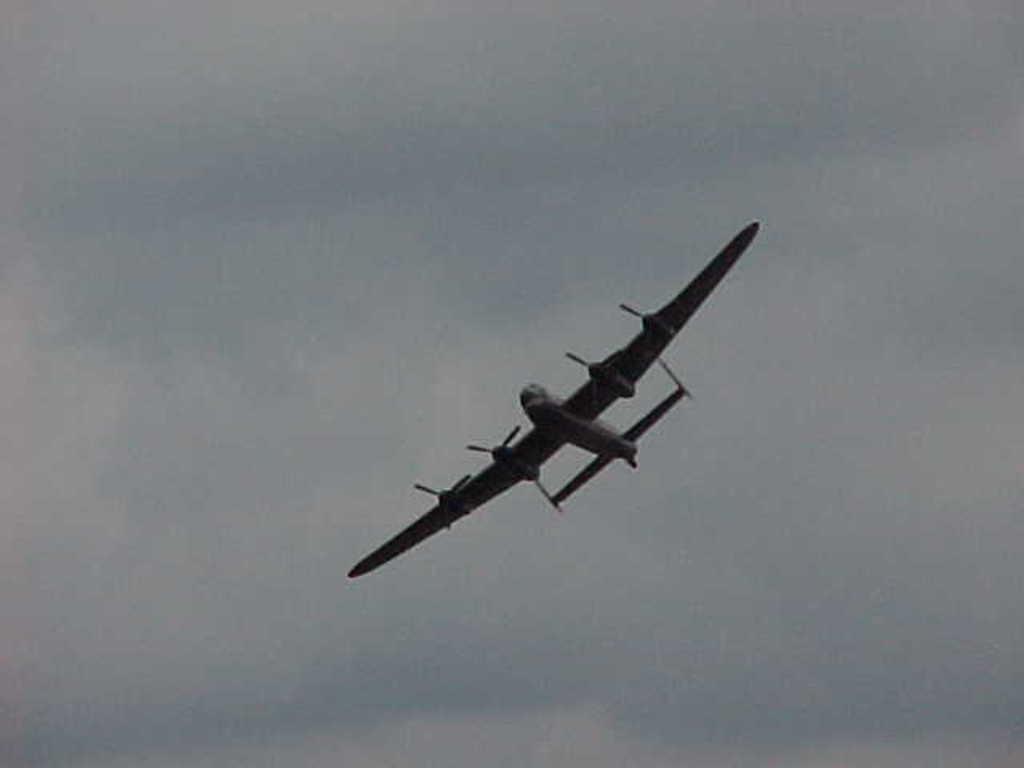Could you give a brief overview of what you see in this image? In this image we can see an aircraft is flying in the air. In the background, we can see the sky with clouds. 